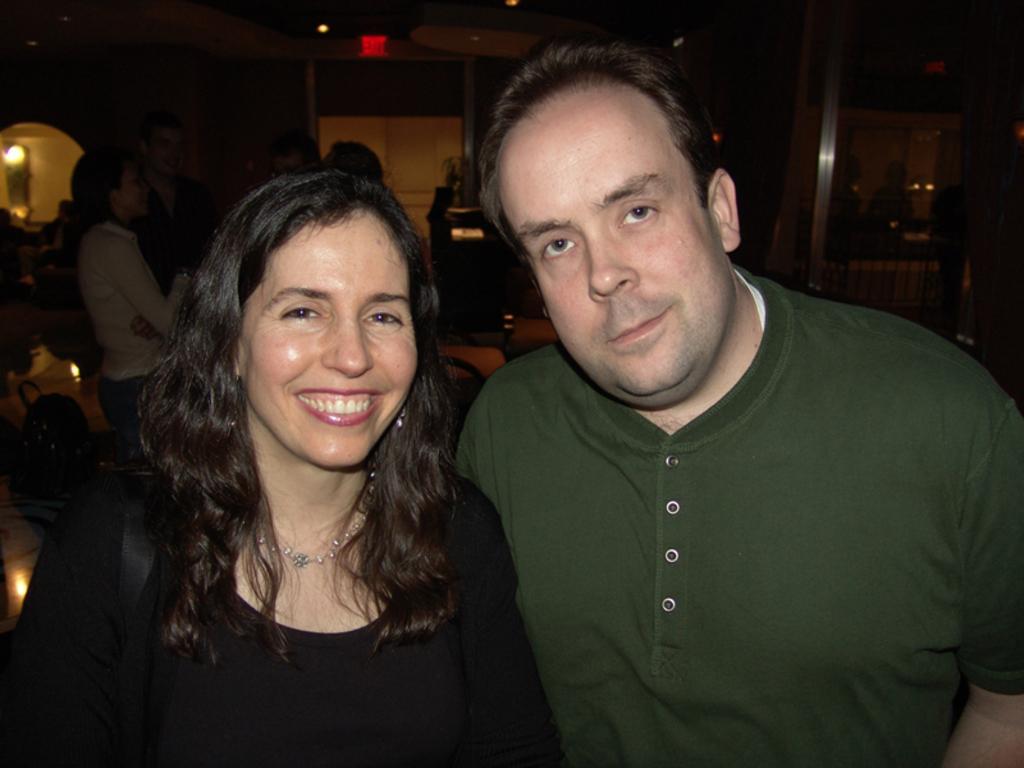Can you describe this image briefly? In this picture there is a man who is wearing green t-shirt. He is standing near to the woman who is wearing black dress. On the left background there are two persons talking with each other. On the right background there is a man who is standing near to the tables. In the background we can see exit sign board, door and desk. 